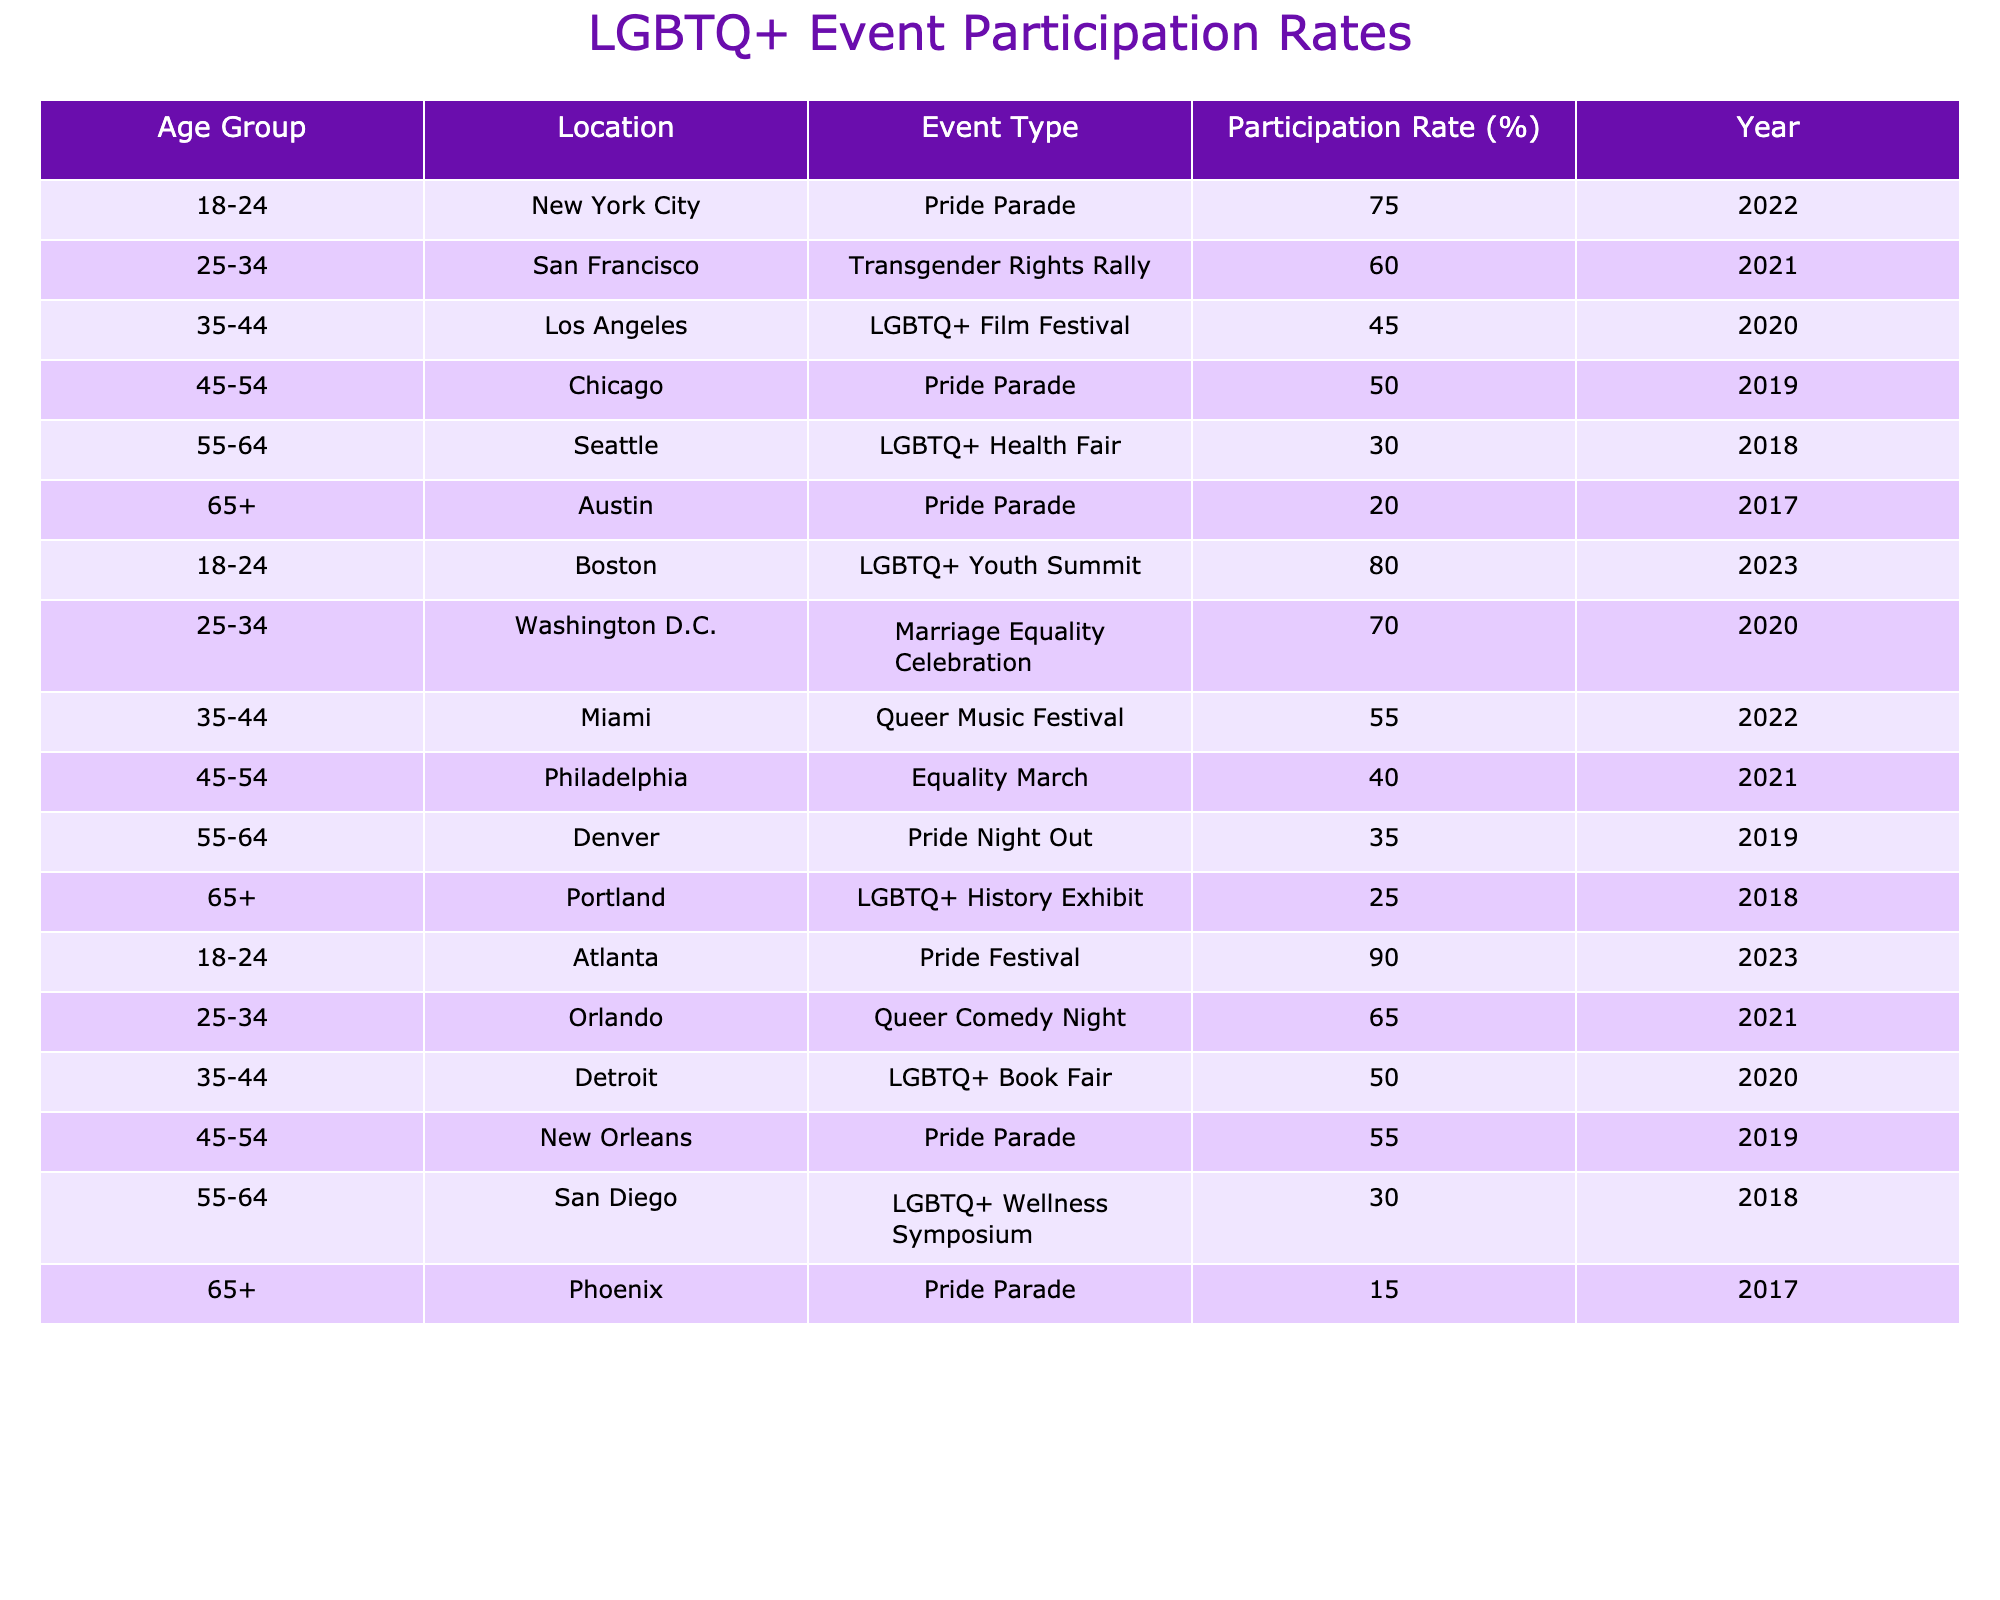What is the participation rate for people aged 18-24 in the Atlanta Pride Festival? The table shows that the participation rate for the 18-24 age group in the Atlanta Pride Festival is 90%.
Answer: 90% Which location had the highest participation rate among those aged 45-54? In the table, the Pride Parade in New Orleans had the highest participation rate for the 45-54 age group at 55%.
Answer: 55% Is the participation rate for the 35-44 age group in Miami higher than in Los Angeles? The participation rate for the 35-44 age group in Miami is 55%, while in Los Angeles, it is 45%, so yes, it is higher in Miami.
Answer: Yes What is the average participation rate for individuals aged 55-64 across all events? Summing the participation rates for the 55-64 age group gives: (30 + 35 + 30) = 95. There are three data points, so the average is 95/3 ≈ 31.67%.
Answer: 31.67% Which age group has the lowest participation rate in the recorded events? The age group 65+ has the lowest participation rate at 15% during the Pride Parade in Phoenix.
Answer: 15% In which year was the LGBTQ+ Youth Summit held, and what was the participation rate? The table indicates that the LGBTQ+ Youth Summit took place in 2023 and had an 80% participation rate.
Answer: 2023, 80% How many events had a participation rate of 60% or more for those aged 25-34, and what are their locations? The events with 60% or more participation for the 25-34 age group are in San Francisco (60%) and Washington D.C. (70%). Thus, there are two such events.
Answer: 2 events Which event has the lowest overall participation rate regardless of age? The event with the lowest overall participation rate in the table is the Pride Parade in Phoenix, with a rate of 15%.
Answer: 15% Is there a trend in participation rates as age increases for the events listed? Observing the data, it appears that participation rates generally decrease as age increases, indicating a possible trend.
Answer: Yes What is the participation rate difference between the Pride Parade in New York City and the Equality March in Philadelphia for participants aged 45-54? The participation rate for the Pride Parade in New York City is 50%, while for the Equality March in Philadelphia, it is 40%. The difference is 50% - 40% = 10%.
Answer: 10% 